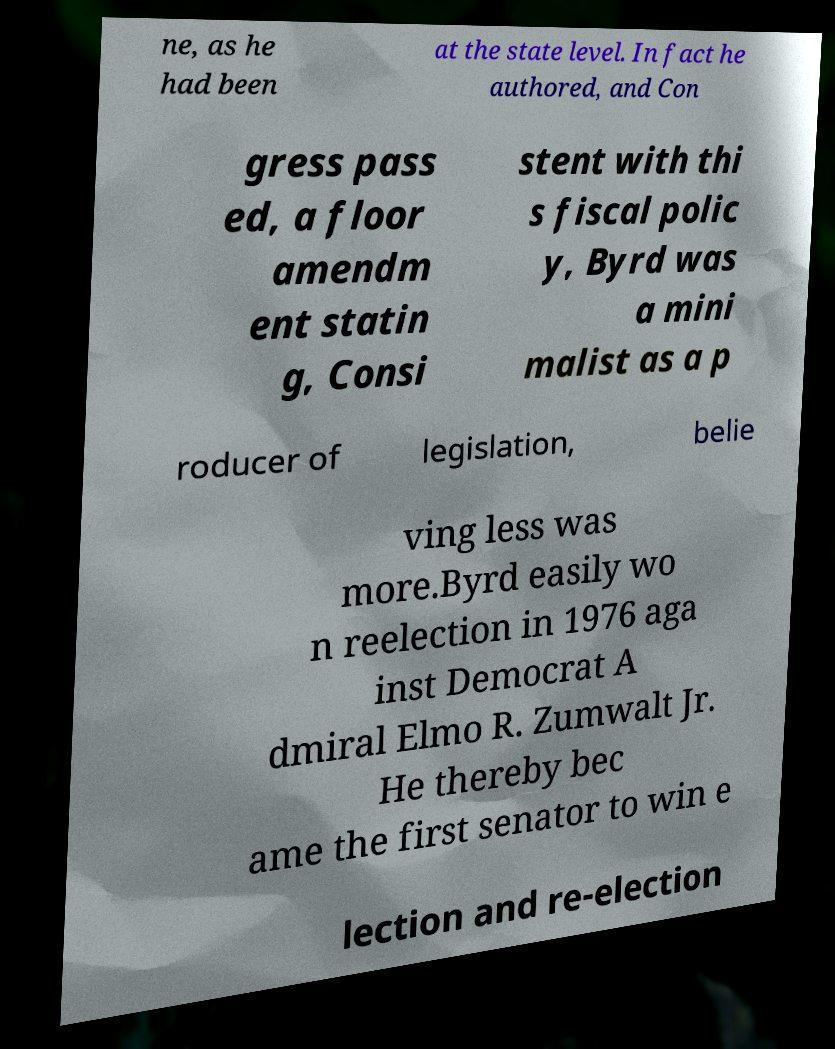Please identify and transcribe the text found in this image. ne, as he had been at the state level. In fact he authored, and Con gress pass ed, a floor amendm ent statin g, Consi stent with thi s fiscal polic y, Byrd was a mini malist as a p roducer of legislation, belie ving less was more.Byrd easily wo n reelection in 1976 aga inst Democrat A dmiral Elmo R. Zumwalt Jr. He thereby bec ame the first senator to win e lection and re-election 